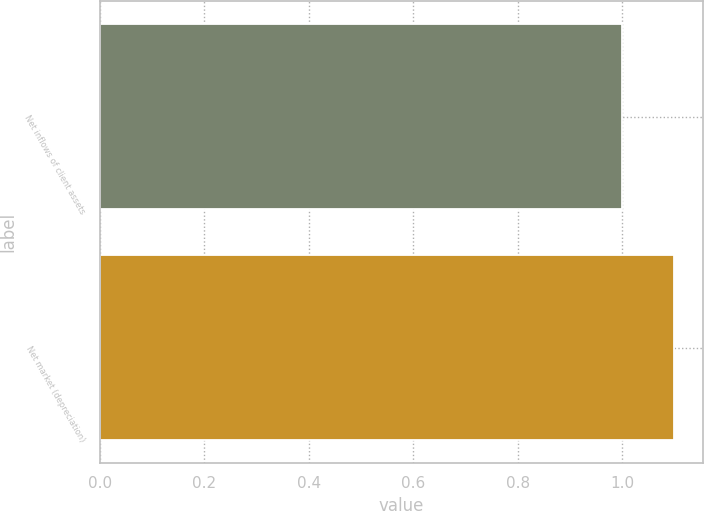Convert chart to OTSL. <chart><loc_0><loc_0><loc_500><loc_500><bar_chart><fcel>Net inflows of client assets<fcel>Net market (depreciation)<nl><fcel>1<fcel>1.1<nl></chart> 